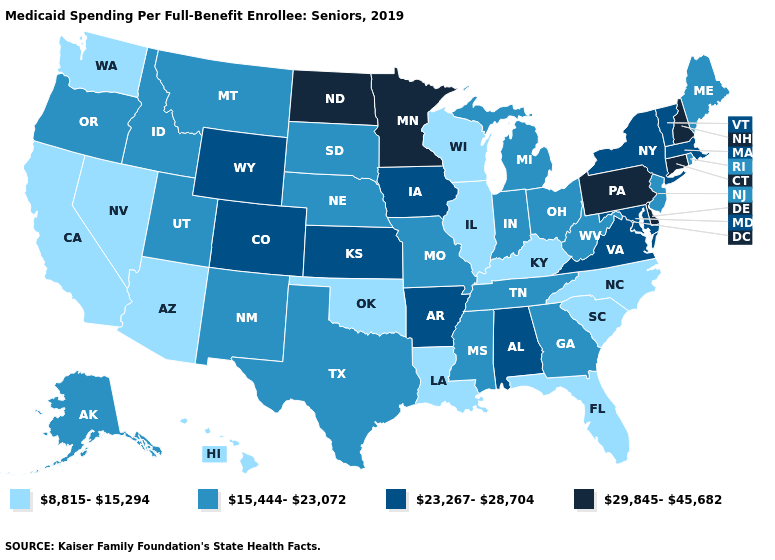Does Kentucky have a lower value than Minnesota?
Concise answer only. Yes. Does New Hampshire have the highest value in the USA?
Concise answer only. Yes. Name the states that have a value in the range 15,444-23,072?
Short answer required. Alaska, Georgia, Idaho, Indiana, Maine, Michigan, Mississippi, Missouri, Montana, Nebraska, New Jersey, New Mexico, Ohio, Oregon, Rhode Island, South Dakota, Tennessee, Texas, Utah, West Virginia. What is the lowest value in the Northeast?
Keep it brief. 15,444-23,072. What is the value of Wisconsin?
Short answer required. 8,815-15,294. What is the highest value in the USA?
Concise answer only. 29,845-45,682. Name the states that have a value in the range 8,815-15,294?
Write a very short answer. Arizona, California, Florida, Hawaii, Illinois, Kentucky, Louisiana, Nevada, North Carolina, Oklahoma, South Carolina, Washington, Wisconsin. Which states hav the highest value in the MidWest?
Short answer required. Minnesota, North Dakota. Among the states that border Massachusetts , which have the lowest value?
Be succinct. Rhode Island. Name the states that have a value in the range 8,815-15,294?
Write a very short answer. Arizona, California, Florida, Hawaii, Illinois, Kentucky, Louisiana, Nevada, North Carolina, Oklahoma, South Carolina, Washington, Wisconsin. What is the lowest value in the West?
Concise answer only. 8,815-15,294. Name the states that have a value in the range 15,444-23,072?
Give a very brief answer. Alaska, Georgia, Idaho, Indiana, Maine, Michigan, Mississippi, Missouri, Montana, Nebraska, New Jersey, New Mexico, Ohio, Oregon, Rhode Island, South Dakota, Tennessee, Texas, Utah, West Virginia. Among the states that border Arkansas , does Missouri have the lowest value?
Keep it brief. No. Which states have the lowest value in the USA?
Write a very short answer. Arizona, California, Florida, Hawaii, Illinois, Kentucky, Louisiana, Nevada, North Carolina, Oklahoma, South Carolina, Washington, Wisconsin. What is the lowest value in states that border Vermont?
Short answer required. 23,267-28,704. 